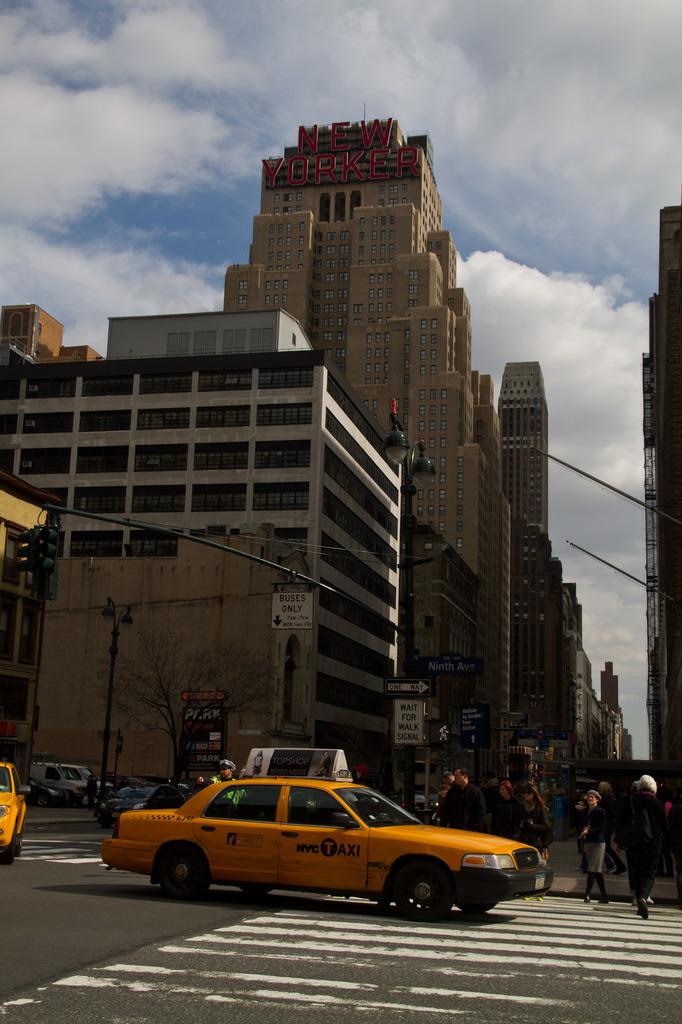What us city is the taxi from?
Offer a terse response. Nyc. 